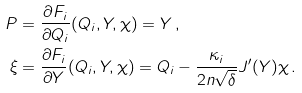<formula> <loc_0><loc_0><loc_500><loc_500>P & = \frac { \partial F _ { i } } { \partial Q _ { i } } ( Q _ { i } , Y , \chi ) = Y \, , \\ \xi & = \frac { \partial F _ { i } } { \partial Y } ( Q _ { i } , Y , \chi ) = Q _ { i } - \frac { \kappa _ { i } } { 2 n \sqrt { \delta } } J ^ { \prime } ( Y ) \chi \, .</formula> 